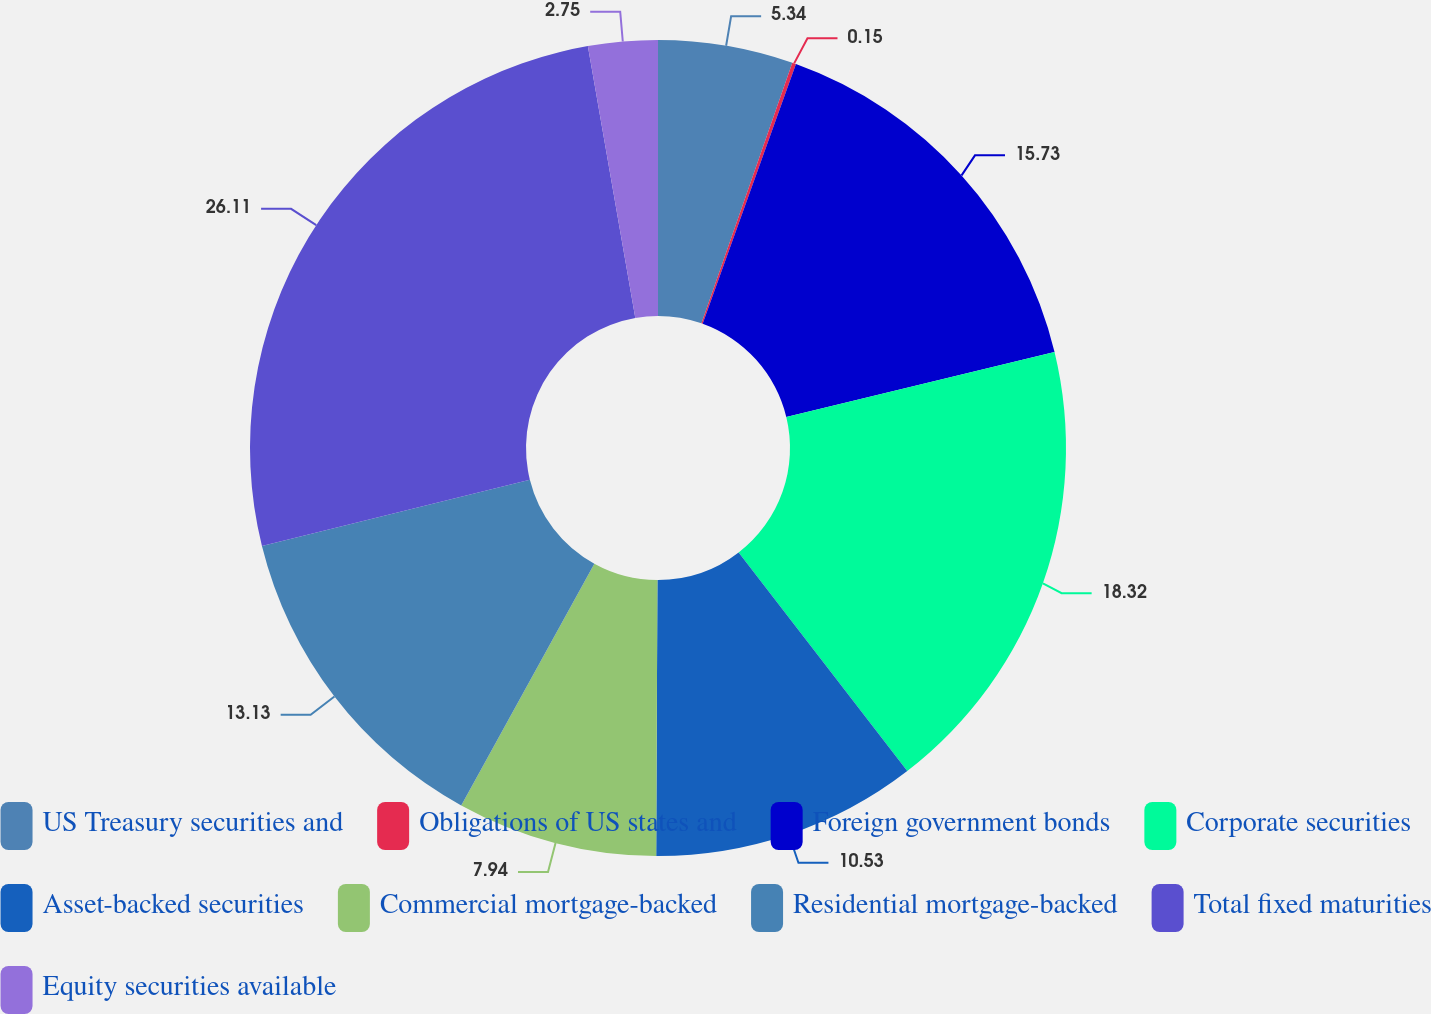<chart> <loc_0><loc_0><loc_500><loc_500><pie_chart><fcel>US Treasury securities and<fcel>Obligations of US states and<fcel>Foreign government bonds<fcel>Corporate securities<fcel>Asset-backed securities<fcel>Commercial mortgage-backed<fcel>Residential mortgage-backed<fcel>Total fixed maturities<fcel>Equity securities available<nl><fcel>5.34%<fcel>0.15%<fcel>15.73%<fcel>18.32%<fcel>10.53%<fcel>7.94%<fcel>13.13%<fcel>26.11%<fcel>2.75%<nl></chart> 